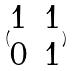<formula> <loc_0><loc_0><loc_500><loc_500>( \begin{matrix} 1 & 1 \\ 0 & 1 \\ \end{matrix} )</formula> 